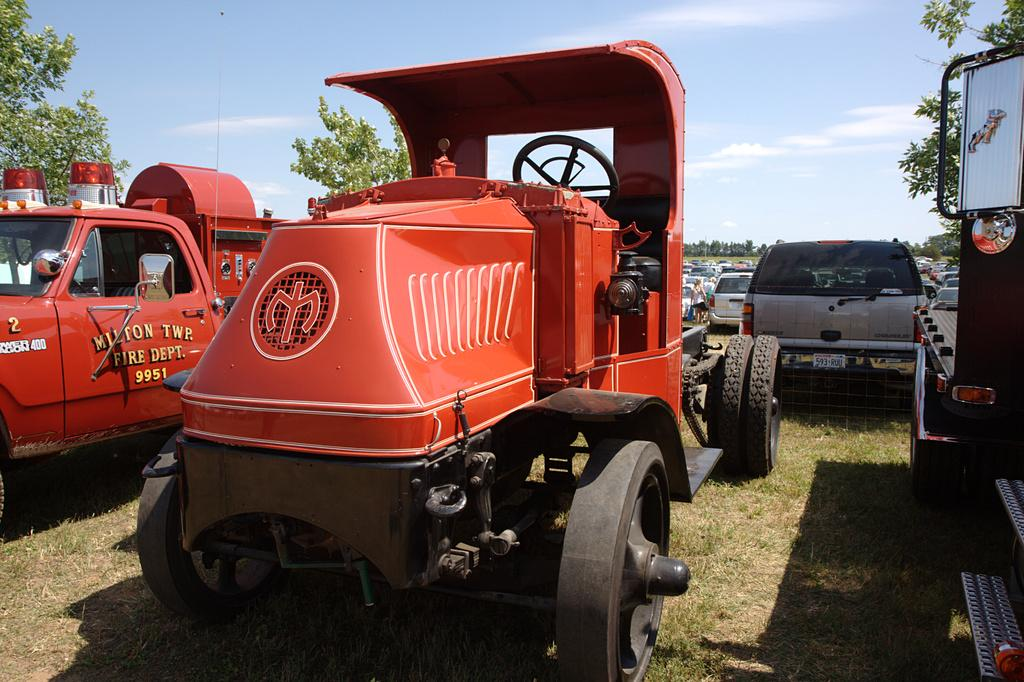What types of vehicles can be seen in the image? There are different types of vehicles in the image. Where are the vehicles located? The vehicles are parked on land. What is the ground surface like where the vehicles are parked? The land is covered with grass. Are there any other natural elements visible in the image? Yes, there are trees around the vehicles. What type of flame can be seen coming from the vehicles in the image? There is no flame present in the image; the vehicles are parked and not in use. 